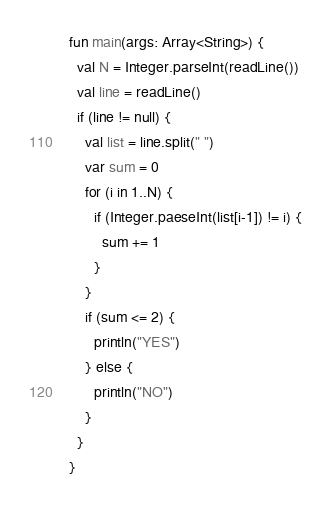<code> <loc_0><loc_0><loc_500><loc_500><_Kotlin_>fun main(args: Array<String>) {
  val N = Integer.parseInt(readLine())
  val line = readLine()
  if (line != null) {
    val list = line.split(" ")
    var sum = 0
    for (i in 1..N) {
      if (Integer.paeseInt(list[i-1]) != i) {
        sum += 1
      }
    }
    if (sum <= 2) {
      println("YES")
    } else {
      println("NO")
    }
  }
}</code> 